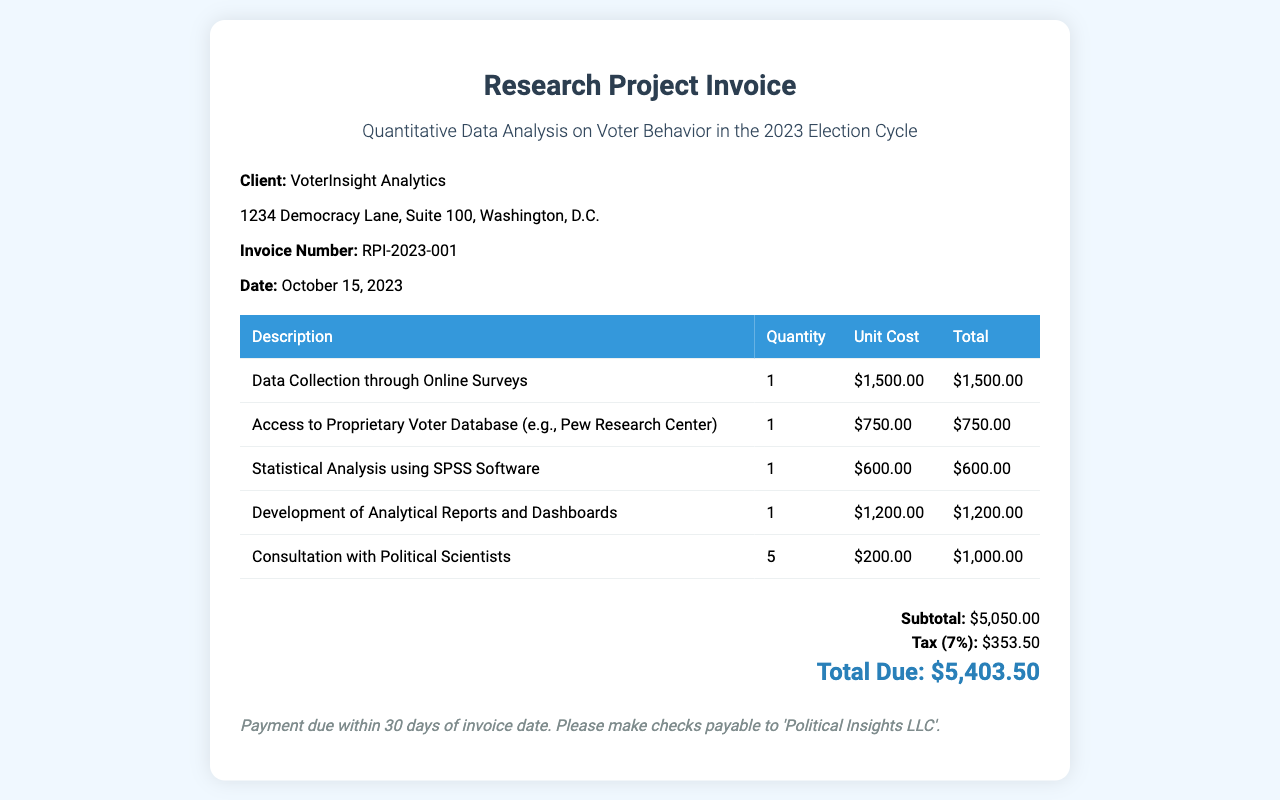what is the invoice number? The invoice number is listed under client information in the document.
Answer: RPI-2023-001 what is the total due amount? The total due amount is found in the summary section of the invoice.
Answer: $5,403.50 how many consultations with political scientists are billed? The number of consultations is provided in the itemized charges in the table.
Answer: 5 what is the subtotal before tax? The subtotal is the total amount before tax, indicated in the summary section.
Answer: $5,050.00 what is the date of the invoice? The date is listed in the client information section of the document.
Answer: October 15, 2023 how much was charged for data collection? The amount charged for data collection is specified in the itemized list in the table.
Answer: $1,500.00 what percentage is the tax applied? The tax percentage on the subtotal is noted in the summary section.
Answer: 7% which organization is the client? The client's name is mentioned at the beginning of the client information section.
Answer: VoterInsight Analytics what is the payment term stated in the document? The payment terms are included at the bottom of the invoice.
Answer: Payment due within 30 days of invoice date 